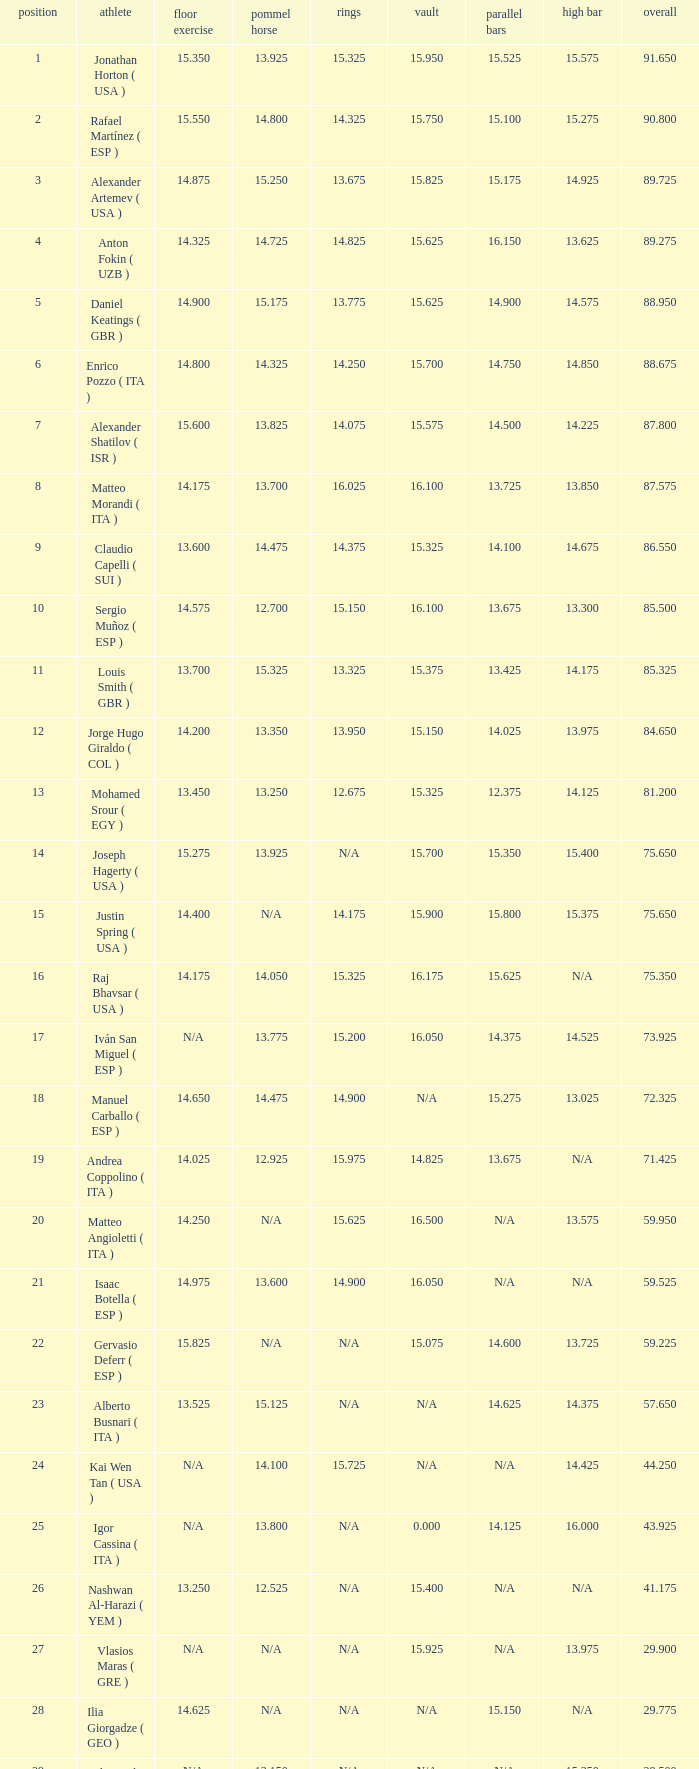If the parallel bars is 14.025, what is the total number of gymnasts? 1.0. 